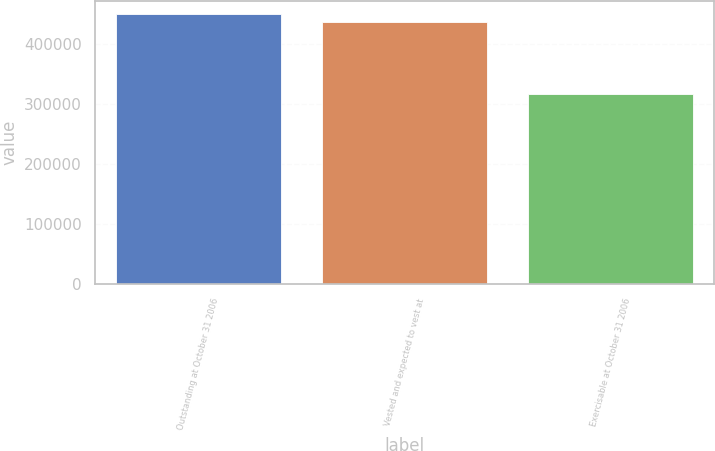Convert chart to OTSL. <chart><loc_0><loc_0><loc_500><loc_500><bar_chart><fcel>Outstanding at October 31 2006<fcel>Vested and expected to vest at<fcel>Exercisable at October 31 2006<nl><fcel>450049<fcel>437109<fcel>316341<nl></chart> 